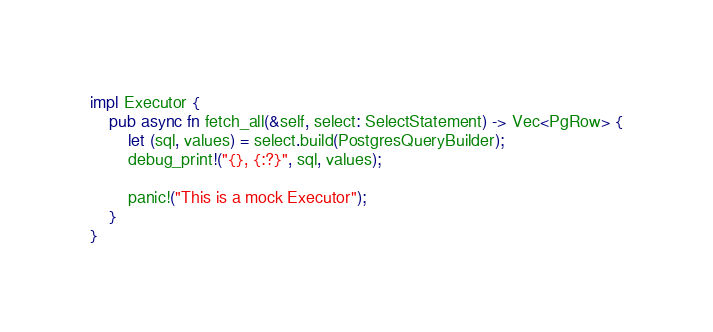<code> <loc_0><loc_0><loc_500><loc_500><_Rust_>
impl Executor {
    pub async fn fetch_all(&self, select: SelectStatement) -> Vec<PgRow> {
        let (sql, values) = select.build(PostgresQueryBuilder);
        debug_print!("{}, {:?}", sql, values);

        panic!("This is a mock Executor");
    }
}
</code> 